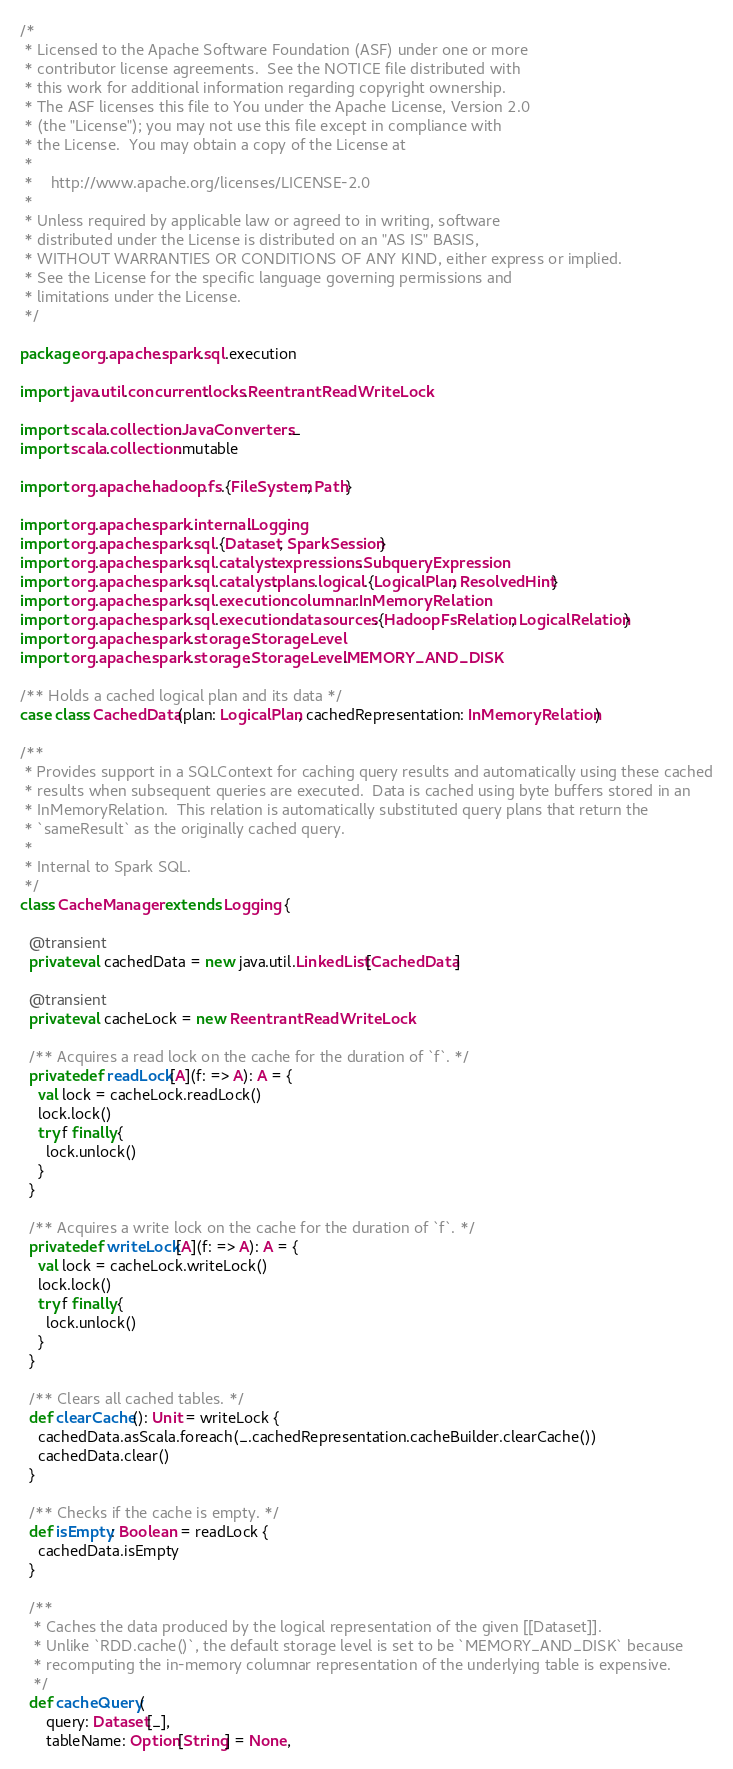Convert code to text. <code><loc_0><loc_0><loc_500><loc_500><_Scala_>/*
 * Licensed to the Apache Software Foundation (ASF) under one or more
 * contributor license agreements.  See the NOTICE file distributed with
 * this work for additional information regarding copyright ownership.
 * The ASF licenses this file to You under the Apache License, Version 2.0
 * (the "License"); you may not use this file except in compliance with
 * the License.  You may obtain a copy of the License at
 *
 *    http://www.apache.org/licenses/LICENSE-2.0
 *
 * Unless required by applicable law or agreed to in writing, software
 * distributed under the License is distributed on an "AS IS" BASIS,
 * WITHOUT WARRANTIES OR CONDITIONS OF ANY KIND, either express or implied.
 * See the License for the specific language governing permissions and
 * limitations under the License.
 */

package org.apache.spark.sql.execution

import java.util.concurrent.locks.ReentrantReadWriteLock

import scala.collection.JavaConverters._
import scala.collection.mutable

import org.apache.hadoop.fs.{FileSystem, Path}

import org.apache.spark.internal.Logging
import org.apache.spark.sql.{Dataset, SparkSession}
import org.apache.spark.sql.catalyst.expressions.SubqueryExpression
import org.apache.spark.sql.catalyst.plans.logical.{LogicalPlan, ResolvedHint}
import org.apache.spark.sql.execution.columnar.InMemoryRelation
import org.apache.spark.sql.execution.datasources.{HadoopFsRelation, LogicalRelation}
import org.apache.spark.storage.StorageLevel
import org.apache.spark.storage.StorageLevel.MEMORY_AND_DISK

/** Holds a cached logical plan and its data */
case class CachedData(plan: LogicalPlan, cachedRepresentation: InMemoryRelation)

/**
 * Provides support in a SQLContext for caching query results and automatically using these cached
 * results when subsequent queries are executed.  Data is cached using byte buffers stored in an
 * InMemoryRelation.  This relation is automatically substituted query plans that return the
 * `sameResult` as the originally cached query.
 *
 * Internal to Spark SQL.
 */
class CacheManager extends Logging {

  @transient
  private val cachedData = new java.util.LinkedList[CachedData]

  @transient
  private val cacheLock = new ReentrantReadWriteLock

  /** Acquires a read lock on the cache for the duration of `f`. */
  private def readLock[A](f: => A): A = {
    val lock = cacheLock.readLock()
    lock.lock()
    try f finally {
      lock.unlock()
    }
  }

  /** Acquires a write lock on the cache for the duration of `f`. */
  private def writeLock[A](f: => A): A = {
    val lock = cacheLock.writeLock()
    lock.lock()
    try f finally {
      lock.unlock()
    }
  }

  /** Clears all cached tables. */
  def clearCache(): Unit = writeLock {
    cachedData.asScala.foreach(_.cachedRepresentation.cacheBuilder.clearCache())
    cachedData.clear()
  }

  /** Checks if the cache is empty. */
  def isEmpty: Boolean = readLock {
    cachedData.isEmpty
  }

  /**
   * Caches the data produced by the logical representation of the given [[Dataset]].
   * Unlike `RDD.cache()`, the default storage level is set to be `MEMORY_AND_DISK` because
   * recomputing the in-memory columnar representation of the underlying table is expensive.
   */
  def cacheQuery(
      query: Dataset[_],
      tableName: Option[String] = None,</code> 